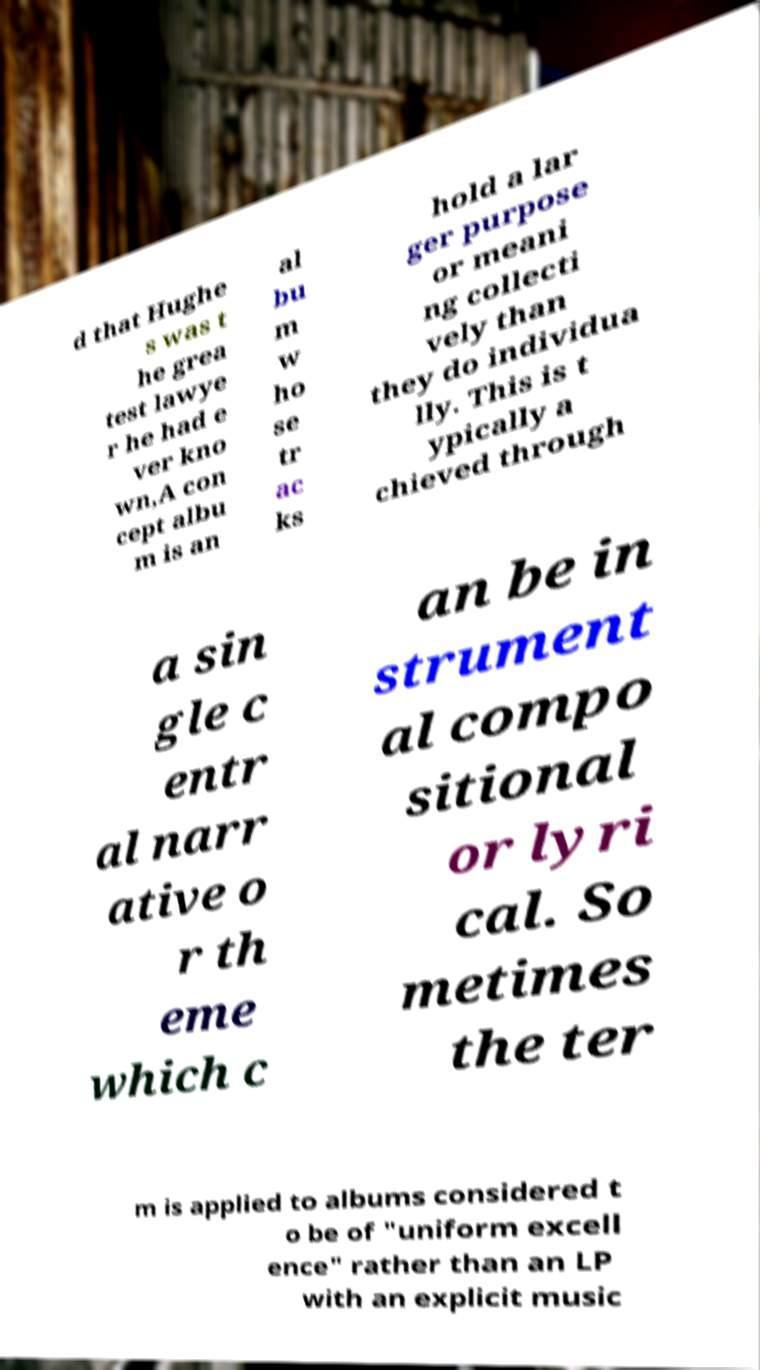What messages or text are displayed in this image? I need them in a readable, typed format. d that Hughe s was t he grea test lawye r he had e ver kno wn,A con cept albu m is an al bu m w ho se tr ac ks hold a lar ger purpose or meani ng collecti vely than they do individua lly. This is t ypically a chieved through a sin gle c entr al narr ative o r th eme which c an be in strument al compo sitional or lyri cal. So metimes the ter m is applied to albums considered t o be of "uniform excell ence" rather than an LP with an explicit music 